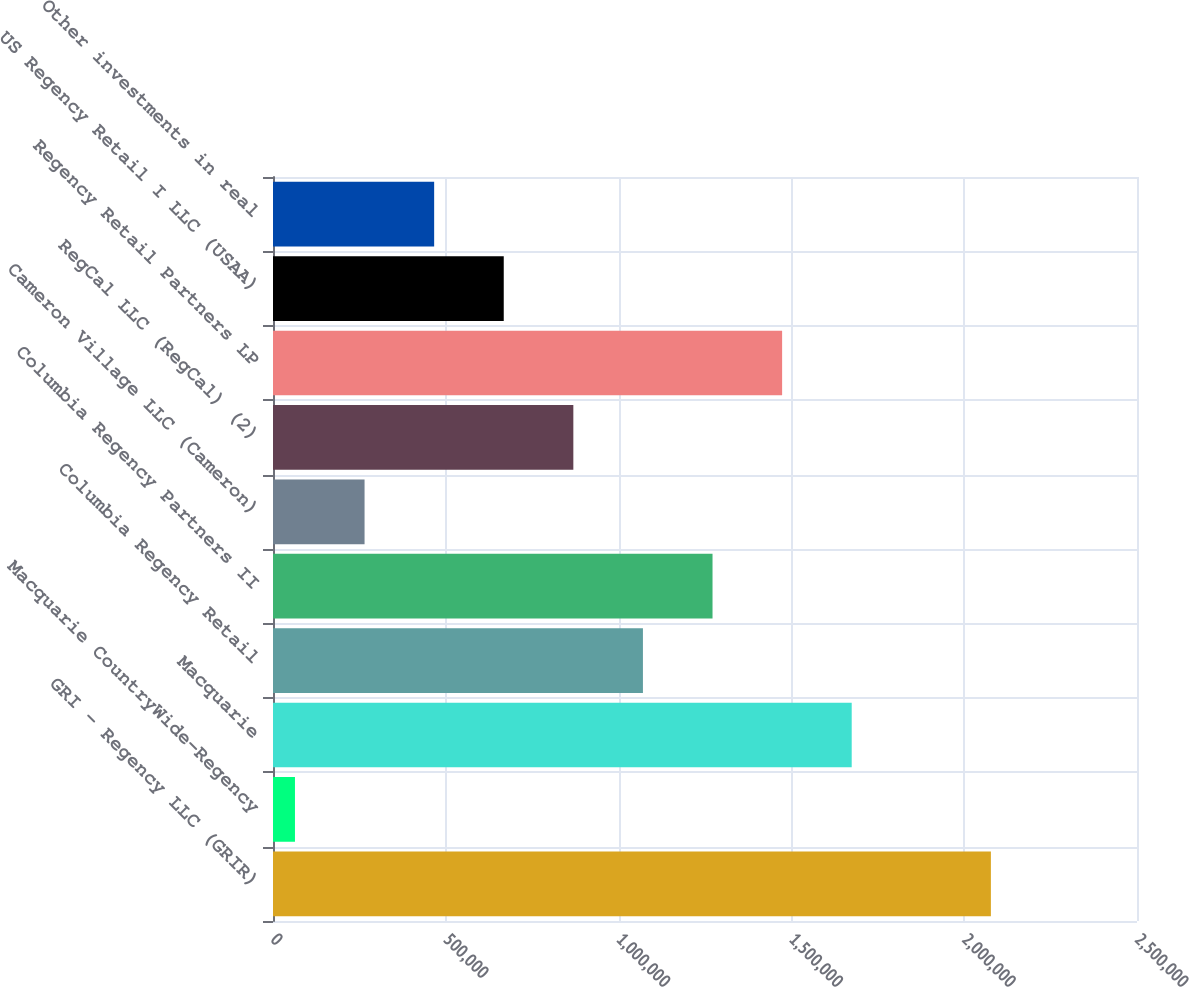<chart> <loc_0><loc_0><loc_500><loc_500><bar_chart><fcel>GRI - Regency LLC (GRIR)<fcel>Macquarie CountryWide-Regency<fcel>Macquarie<fcel>Columbia Regency Retail<fcel>Columbia Regency Partners II<fcel>Cameron Village LLC (Cameron)<fcel>RegCal LLC (RegCal) (2)<fcel>Regency Retail Partners LP<fcel>US Regency Retail I LLC (USAA)<fcel>Other investments in real<nl><fcel>2.07724e+06<fcel>63575<fcel>1.67451e+06<fcel>1.07041e+06<fcel>1.27177e+06<fcel>264942<fcel>869041<fcel>1.47314e+06<fcel>667674<fcel>466308<nl></chart> 